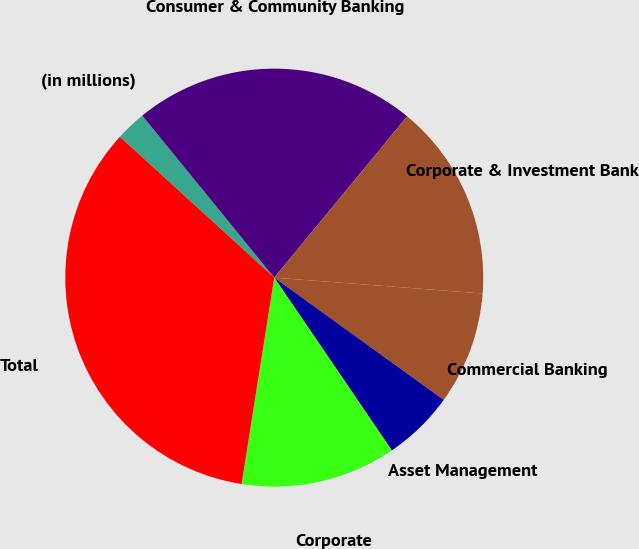Convert chart to OTSL. <chart><loc_0><loc_0><loc_500><loc_500><pie_chart><fcel>(in millions)<fcel>Consumer & Community Banking<fcel>Corporate & Investment Bank<fcel>Commercial Banking<fcel>Asset Management<fcel>Corporate<fcel>Total<nl><fcel>2.35%<fcel>21.85%<fcel>15.24%<fcel>8.74%<fcel>5.54%<fcel>12.01%<fcel>34.27%<nl></chart> 